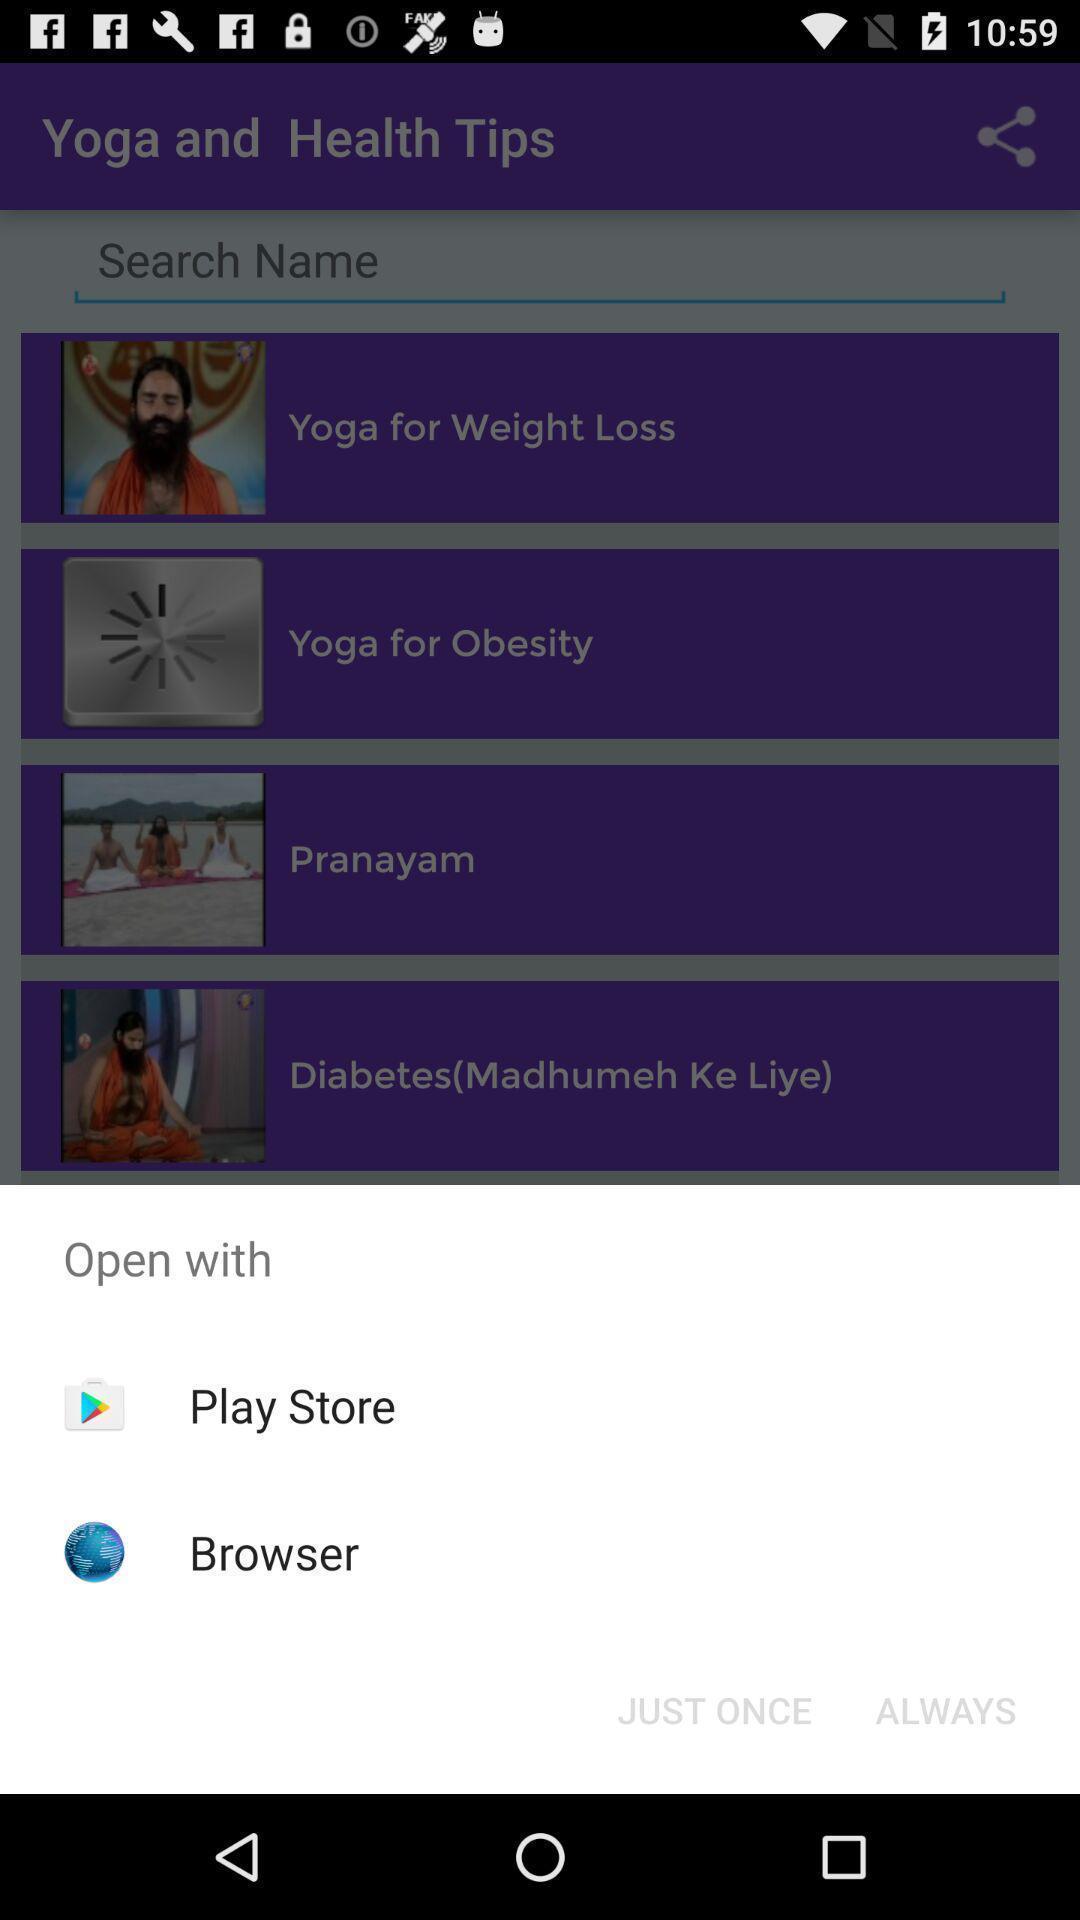Tell me about the visual elements in this screen capture. Popup showing few options with icons in health app. 